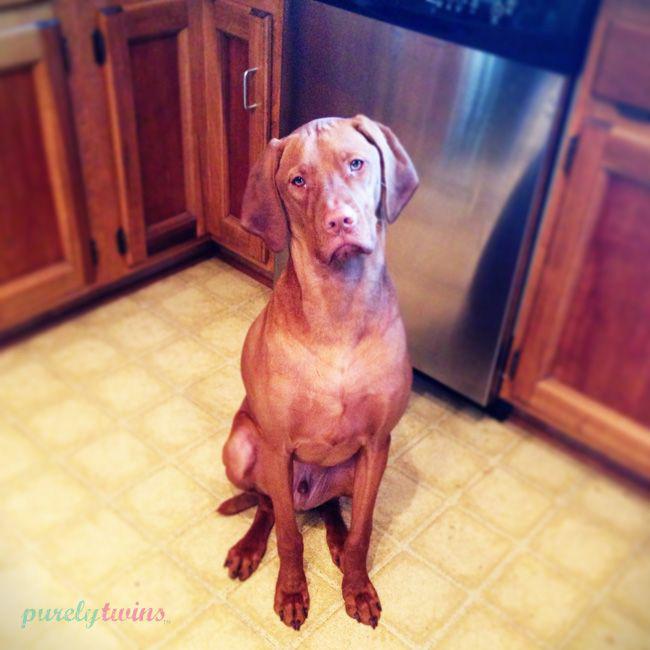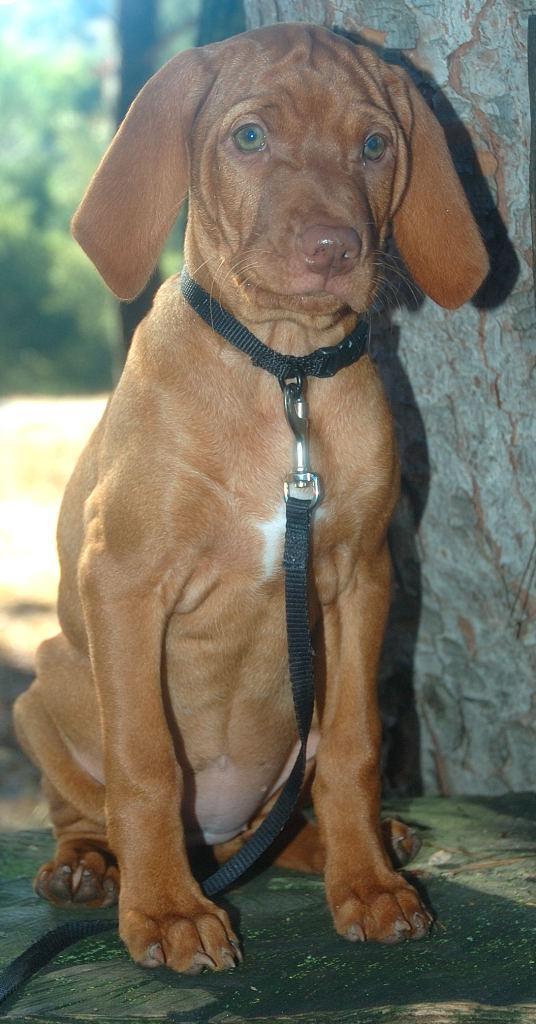The first image is the image on the left, the second image is the image on the right. Examine the images to the left and right. Is the description "A dog is sitting on a tile floor." accurate? Answer yes or no. Yes. The first image is the image on the left, the second image is the image on the right. For the images shown, is this caption "One image shows a red-orange puppy wearing a collar in an upright sitting pose, and the other image shows a puppy with at least one front paw propped on something off the ground." true? Answer yes or no. No. 